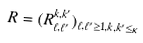Convert formula to latex. <formula><loc_0><loc_0><loc_500><loc_500>R = ( R _ { \ell , \ell ^ { \prime } } ^ { k , k ^ { \prime } } ) _ { \ell , \ell ^ { \prime } \geq 1 , k , k ^ { \prime } \leq \kappa }</formula> 